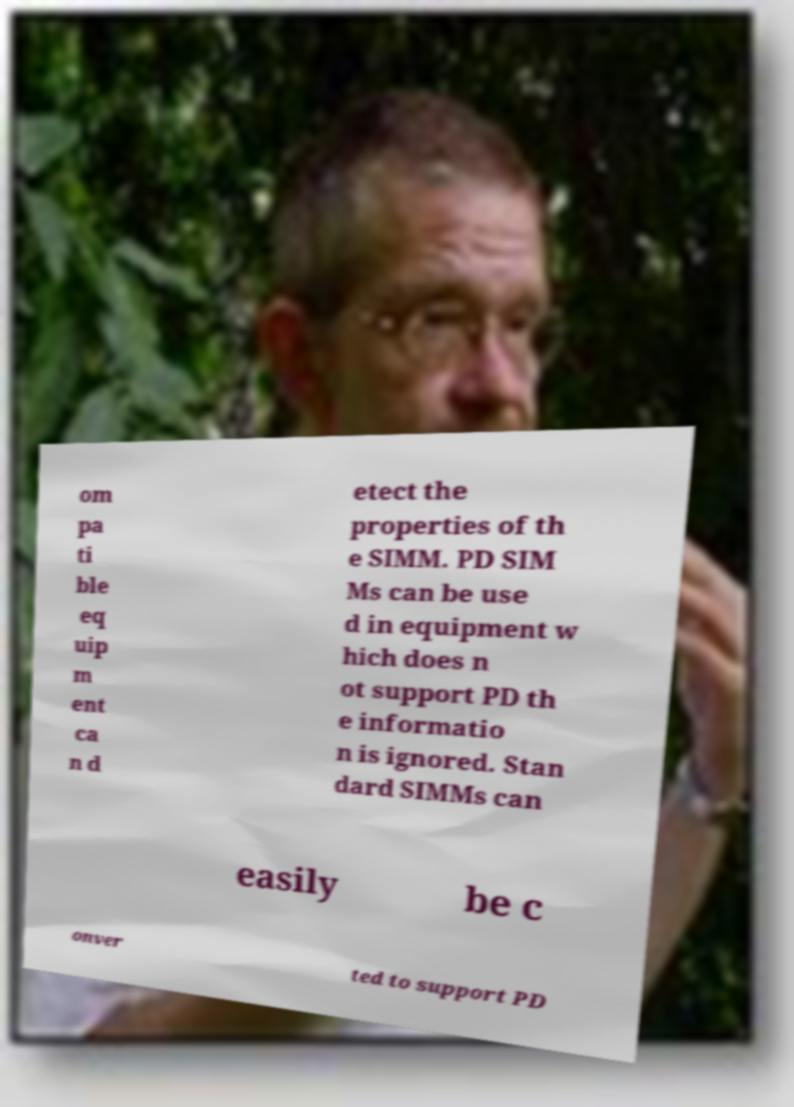Can you read and provide the text displayed in the image?This photo seems to have some interesting text. Can you extract and type it out for me? om pa ti ble eq uip m ent ca n d etect the properties of th e SIMM. PD SIM Ms can be use d in equipment w hich does n ot support PD th e informatio n is ignored. Stan dard SIMMs can easily be c onver ted to support PD 